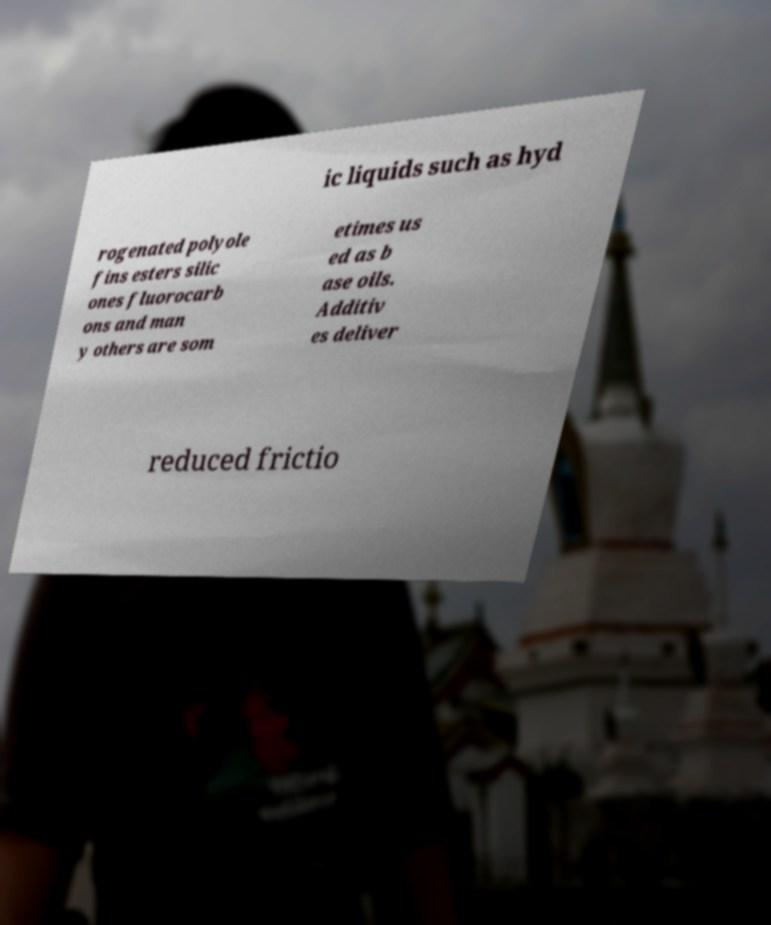Please read and relay the text visible in this image. What does it say? ic liquids such as hyd rogenated polyole fins esters silic ones fluorocarb ons and man y others are som etimes us ed as b ase oils. Additiv es deliver reduced frictio 